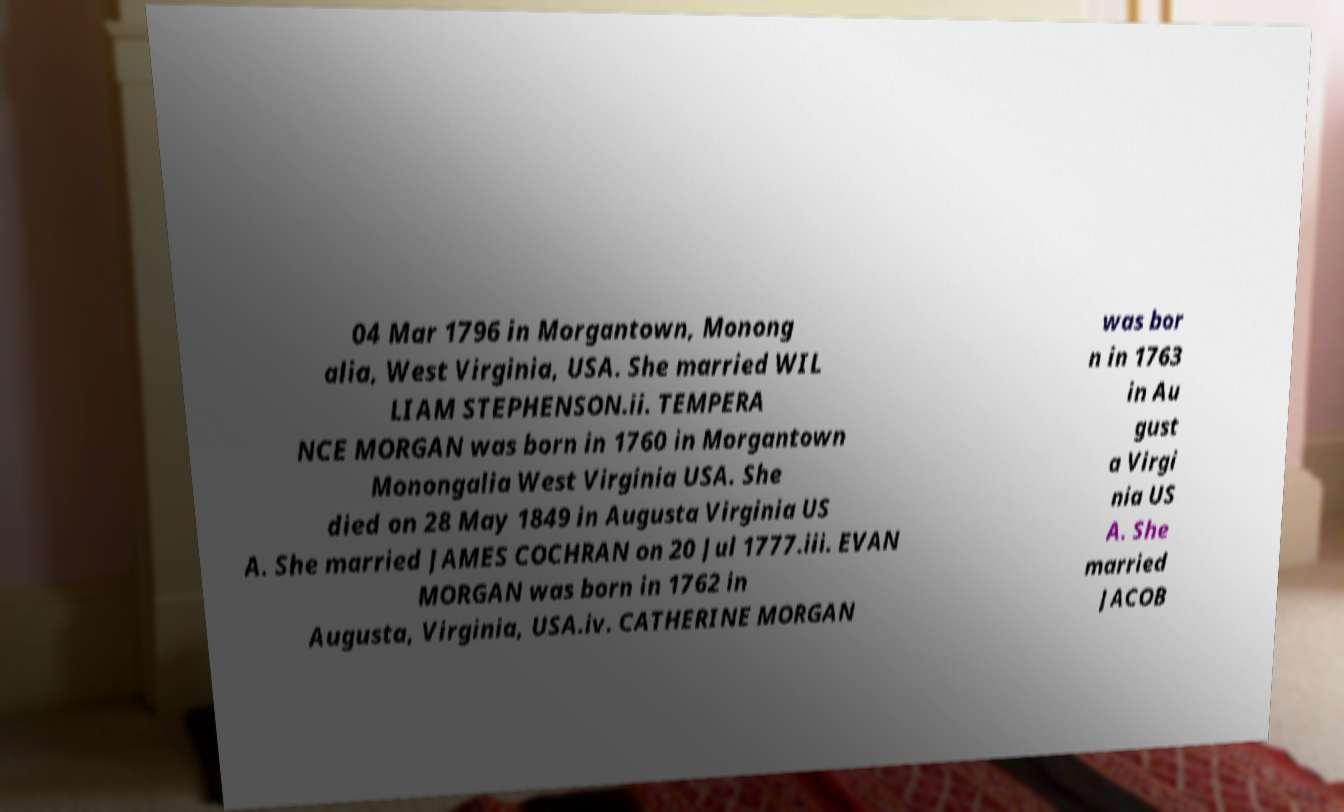Can you read and provide the text displayed in the image?This photo seems to have some interesting text. Can you extract and type it out for me? 04 Mar 1796 in Morgantown, Monong alia, West Virginia, USA. She married WIL LIAM STEPHENSON.ii. TEMPERA NCE MORGAN was born in 1760 in Morgantown Monongalia West Virginia USA. She died on 28 May 1849 in Augusta Virginia US A. She married JAMES COCHRAN on 20 Jul 1777.iii. EVAN MORGAN was born in 1762 in Augusta, Virginia, USA.iv. CATHERINE MORGAN was bor n in 1763 in Au gust a Virgi nia US A. She married JACOB 